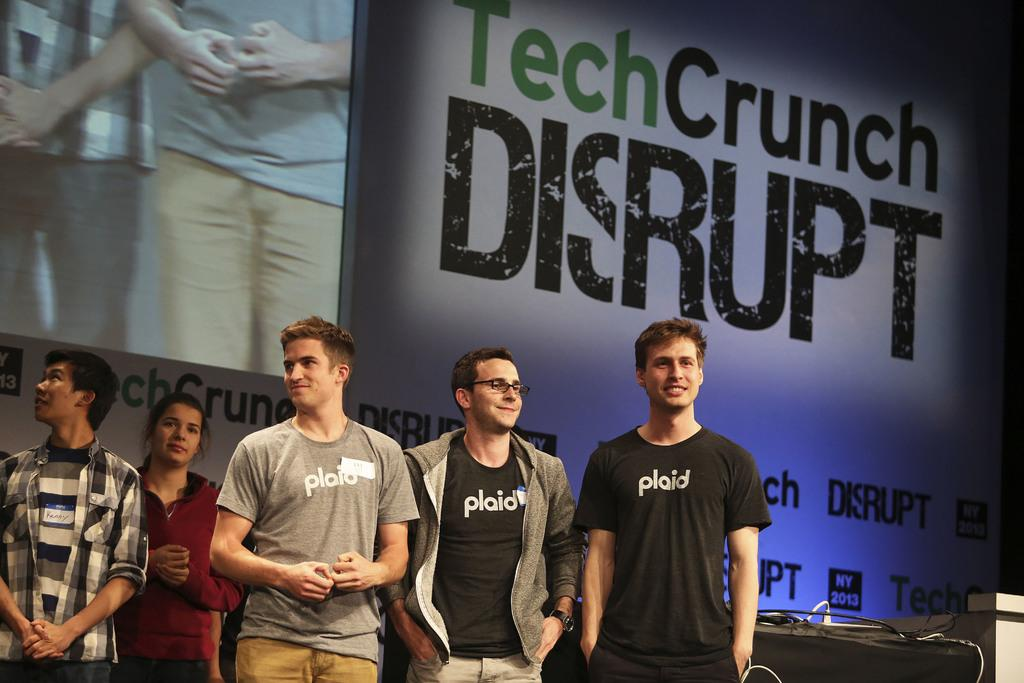What is happening in the image? There are people standing in the image. What can be seen in the background of the image? There is a screen visible in the background of the image. Are there any words or letters in the image? Yes, there is some text in the image. What type of furniture is present in the image? There is a table in the image. What is on top of the table? There are objects on the table. How many legs does the zephyr have in the image? There is no zephyr present in the image, so it is not possible to determine how many legs it might have. 